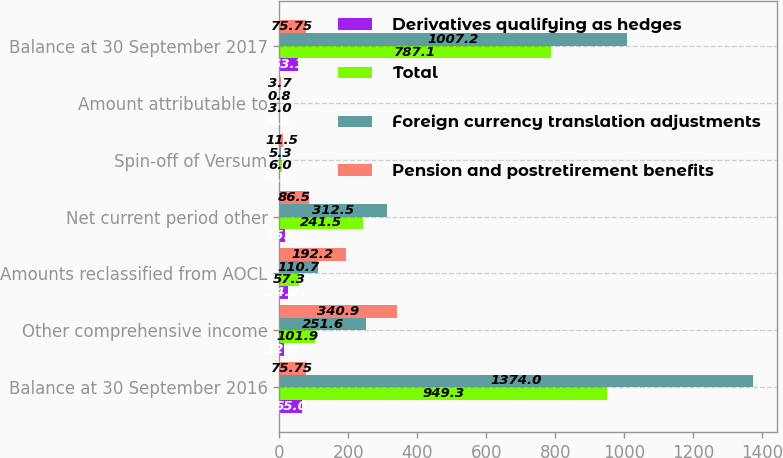<chart> <loc_0><loc_0><loc_500><loc_500><stacked_bar_chart><ecel><fcel>Balance at 30 September 2016<fcel>Other comprehensive income<fcel>Amounts reclassified from AOCL<fcel>Net current period other<fcel>Spin-off of Versum<fcel>Amount attributable to<fcel>Balance at 30 September 2017<nl><fcel>Derivatives qualifying as hedges<fcel>65<fcel>12.6<fcel>24.2<fcel>15.5<fcel>0.2<fcel>0.1<fcel>53.1<nl><fcel>Total<fcel>949.3<fcel>101.9<fcel>57.3<fcel>241.5<fcel>6<fcel>3<fcel>787.1<nl><fcel>Foreign currency translation adjustments<fcel>1374<fcel>251.6<fcel>110.7<fcel>312.5<fcel>5.3<fcel>0.8<fcel>1007.2<nl><fcel>Pension and postretirement benefits<fcel>75.75<fcel>340.9<fcel>192.2<fcel>86.5<fcel>11.5<fcel>3.7<fcel>75.75<nl></chart> 